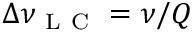<formula> <loc_0><loc_0><loc_500><loc_500>\Delta \nu _ { L C } = \nu / Q</formula> 